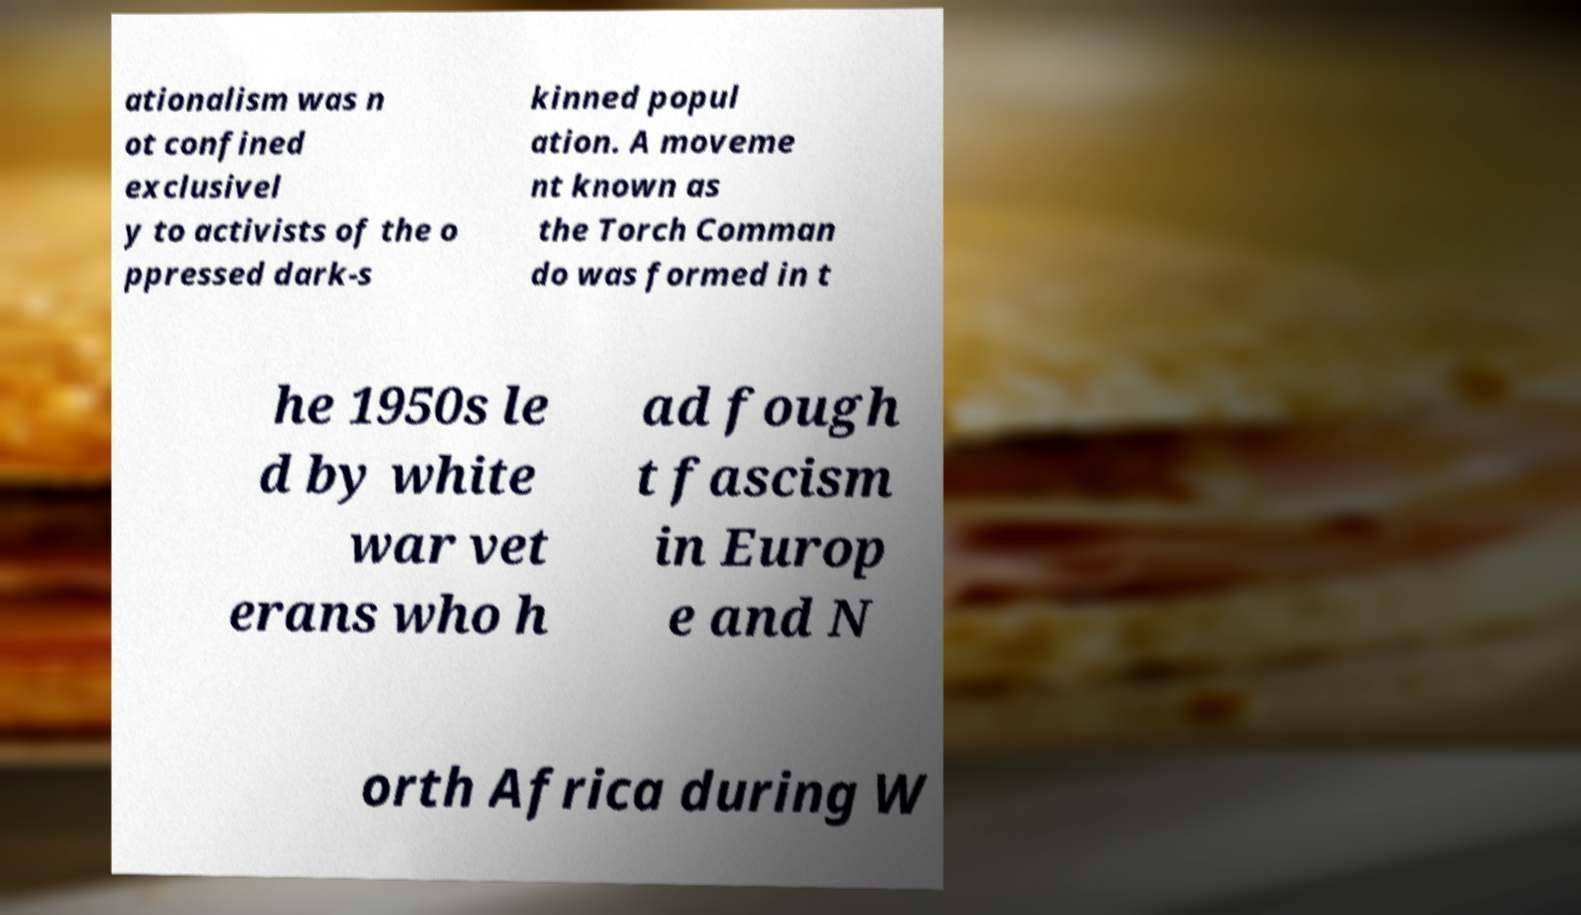There's text embedded in this image that I need extracted. Can you transcribe it verbatim? ationalism was n ot confined exclusivel y to activists of the o ppressed dark-s kinned popul ation. A moveme nt known as the Torch Comman do was formed in t he 1950s le d by white war vet erans who h ad fough t fascism in Europ e and N orth Africa during W 